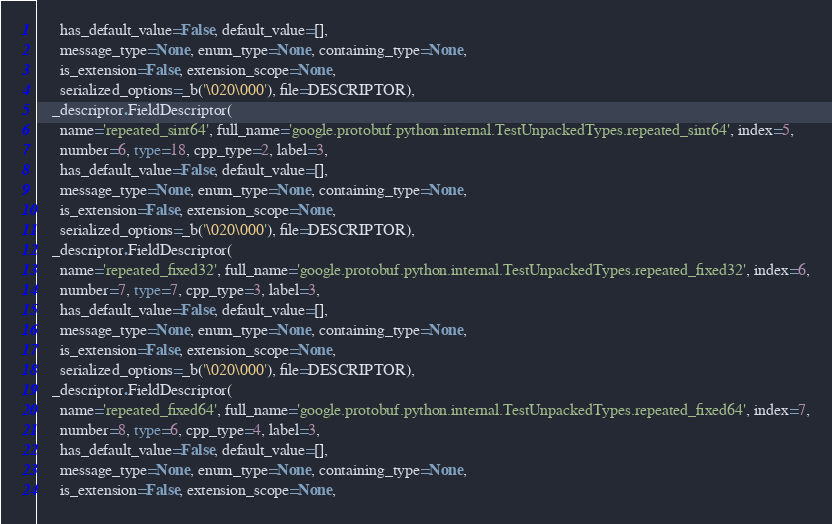Convert code to text. <code><loc_0><loc_0><loc_500><loc_500><_Python_>      has_default_value=False, default_value=[],
      message_type=None, enum_type=None, containing_type=None,
      is_extension=False, extension_scope=None,
      serialized_options=_b('\020\000'), file=DESCRIPTOR),
    _descriptor.FieldDescriptor(
      name='repeated_sint64', full_name='google.protobuf.python.internal.TestUnpackedTypes.repeated_sint64', index=5,
      number=6, type=18, cpp_type=2, label=3,
      has_default_value=False, default_value=[],
      message_type=None, enum_type=None, containing_type=None,
      is_extension=False, extension_scope=None,
      serialized_options=_b('\020\000'), file=DESCRIPTOR),
    _descriptor.FieldDescriptor(
      name='repeated_fixed32', full_name='google.protobuf.python.internal.TestUnpackedTypes.repeated_fixed32', index=6,
      number=7, type=7, cpp_type=3, label=3,
      has_default_value=False, default_value=[],
      message_type=None, enum_type=None, containing_type=None,
      is_extension=False, extension_scope=None,
      serialized_options=_b('\020\000'), file=DESCRIPTOR),
    _descriptor.FieldDescriptor(
      name='repeated_fixed64', full_name='google.protobuf.python.internal.TestUnpackedTypes.repeated_fixed64', index=7,
      number=8, type=6, cpp_type=4, label=3,
      has_default_value=False, default_value=[],
      message_type=None, enum_type=None, containing_type=None,
      is_extension=False, extension_scope=None,</code> 